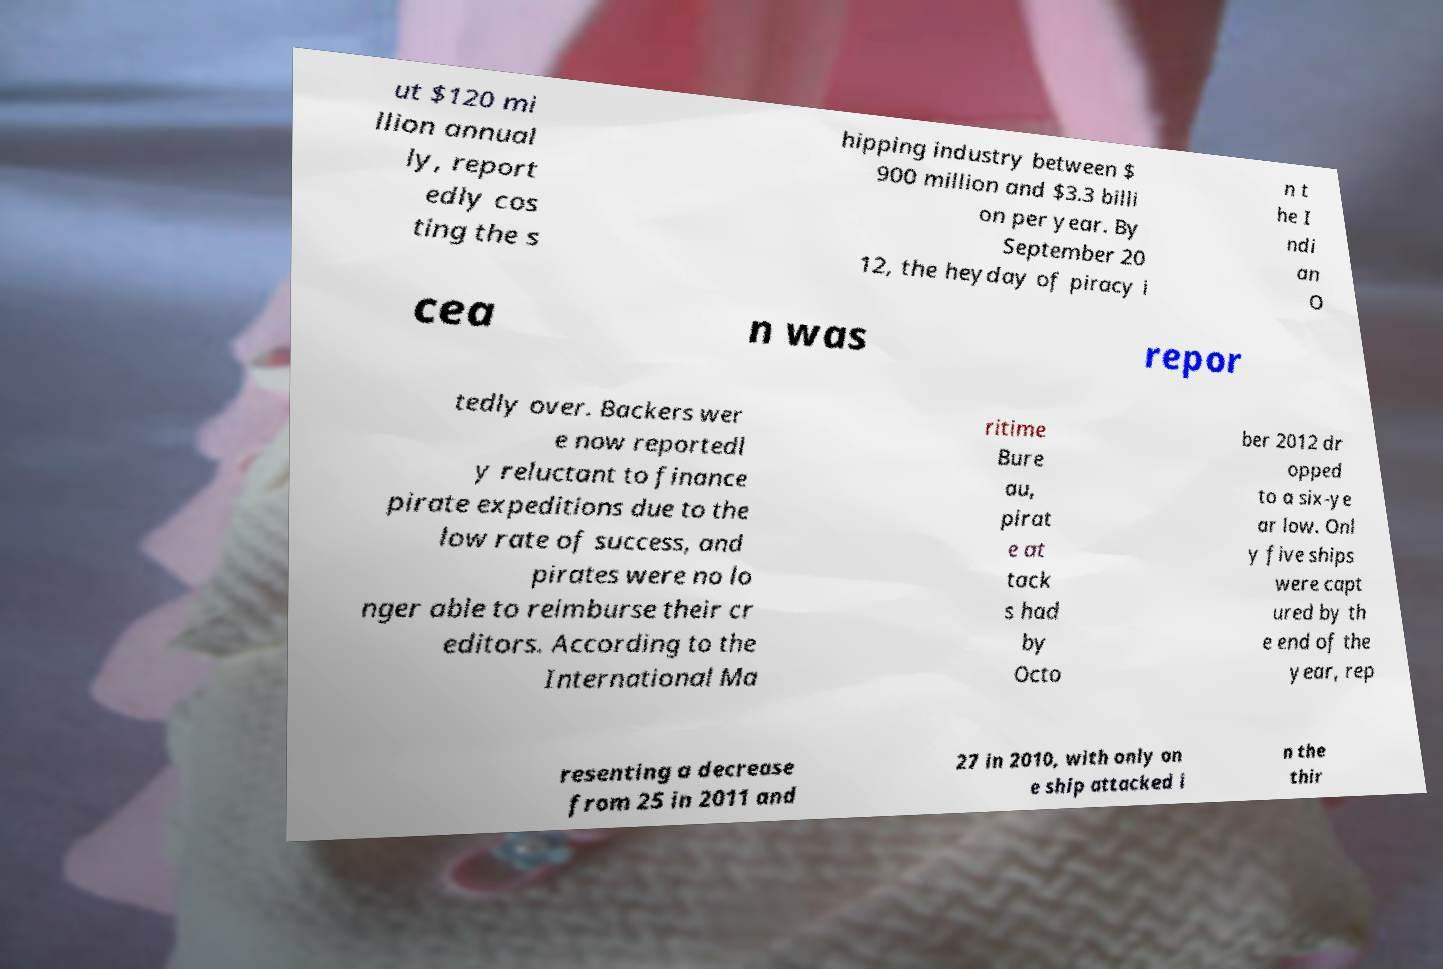What messages or text are displayed in this image? I need them in a readable, typed format. ut $120 mi llion annual ly, report edly cos ting the s hipping industry between $ 900 million and $3.3 billi on per year. By September 20 12, the heyday of piracy i n t he I ndi an O cea n was repor tedly over. Backers wer e now reportedl y reluctant to finance pirate expeditions due to the low rate of success, and pirates were no lo nger able to reimburse their cr editors. According to the International Ma ritime Bure au, pirat e at tack s had by Octo ber 2012 dr opped to a six-ye ar low. Onl y five ships were capt ured by th e end of the year, rep resenting a decrease from 25 in 2011 and 27 in 2010, with only on e ship attacked i n the thir 